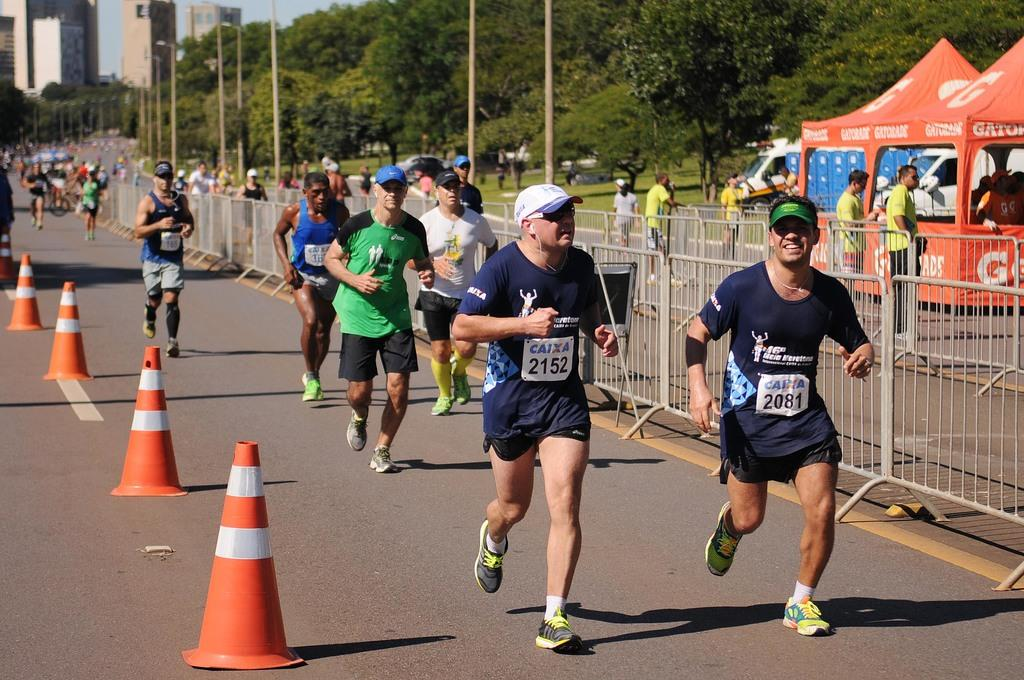What are the people in the image doing? The people in the image are running on the road. What objects are present on the road? There are traffic cones on the road. What can be seen in the background of the image? There are trees, buildings, poles, tents, and vehicles in the background. Is there any barrier or divider visible in the background? Yes, there is a fence in the background. What type of comfort can be found in the selection of tents in the image? There is no mention of comfort or selection in the image; it simply shows tents in the background. 